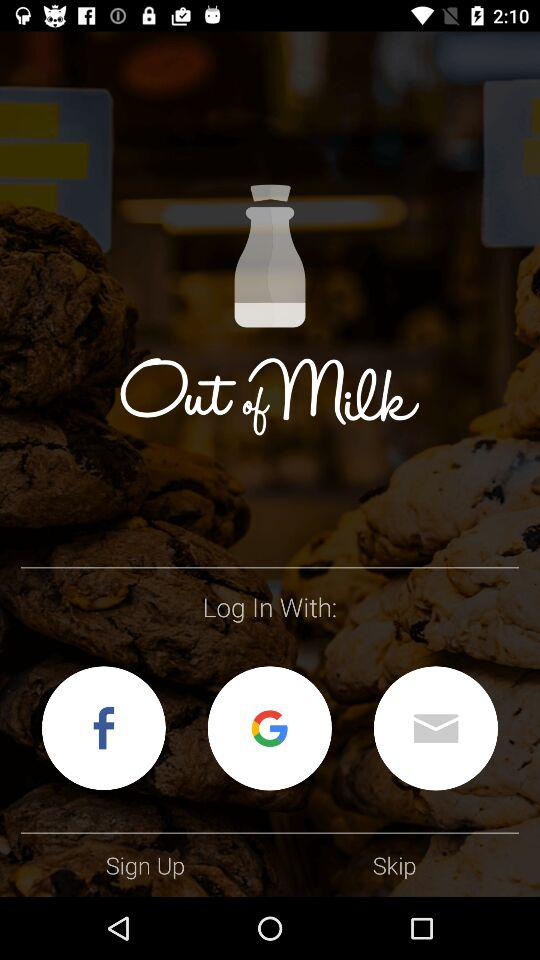How many sign in options are there?
Answer the question using a single word or phrase. 3 